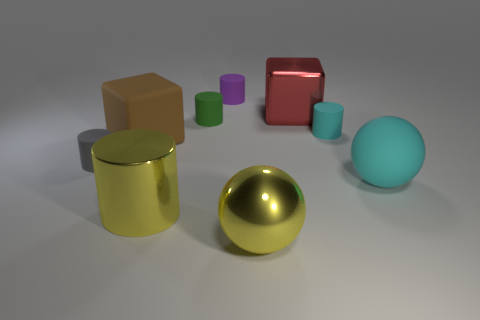What color is the metal cylinder?
Your answer should be very brief. Yellow. There is a sphere in front of the large cyan matte sphere; is there a tiny green cylinder that is on the right side of it?
Provide a succinct answer. No. How many cyan rubber things have the same size as the purple matte thing?
Provide a short and direct response. 1. There is a big yellow thing left of the yellow metal thing that is on the right side of the purple cylinder; what number of large matte things are to the left of it?
Keep it short and to the point. 1. What number of tiny cylinders are to the left of the small purple thing and right of the large metallic cylinder?
Provide a short and direct response. 1. Is there anything else that is the same color as the metallic cube?
Provide a succinct answer. No. What number of matte things are either tiny purple cylinders or big yellow objects?
Make the answer very short. 1. What material is the cyan thing in front of the big matte cube that is to the left of the cylinder that is to the right of the purple thing?
Give a very brief answer. Rubber. There is a cylinder that is in front of the large ball that is behind the yellow metallic ball; what is its material?
Your answer should be very brief. Metal. There is a cyan matte object that is in front of the big brown thing; does it have the same size as the metal object in front of the big yellow metallic cylinder?
Give a very brief answer. Yes. 